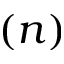<formula> <loc_0><loc_0><loc_500><loc_500>( n )</formula> 